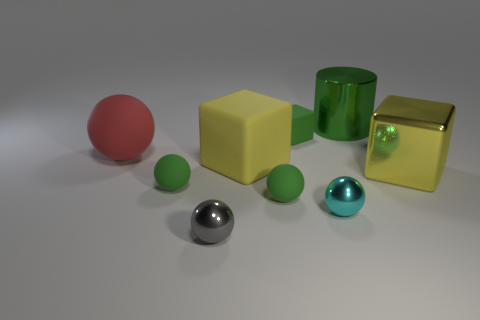What number of small green balls have the same material as the red object?
Ensure brevity in your answer.  2. What is the color of the big block that is the same material as the tiny green cube?
Your answer should be compact. Yellow. There is a tiny cyan shiny object; what shape is it?
Offer a terse response. Sphere. What number of tiny objects are the same color as the big rubber ball?
Your answer should be very brief. 0. There is a cyan thing that is the same size as the green matte block; what is its shape?
Your response must be concise. Sphere. Is there a yellow object of the same size as the red matte thing?
Offer a very short reply. Yes. What is the material of the red ball that is the same size as the green shiny cylinder?
Your answer should be very brief. Rubber. There is a rubber thing that is behind the red matte ball on the left side of the cyan sphere; how big is it?
Keep it short and to the point. Small. There is a cyan metallic object that is behind the gray thing; is its size the same as the large matte block?
Provide a succinct answer. No. Are there more tiny things in front of the tiny cyan thing than tiny cubes that are in front of the big green shiny object?
Give a very brief answer. No. 